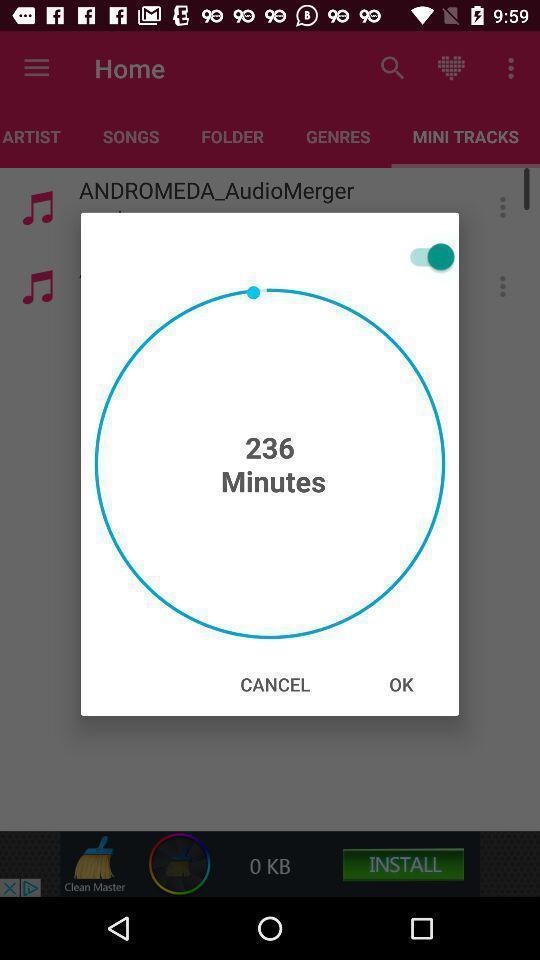Describe the key features of this screenshot. Pop-up showing on a music app. 